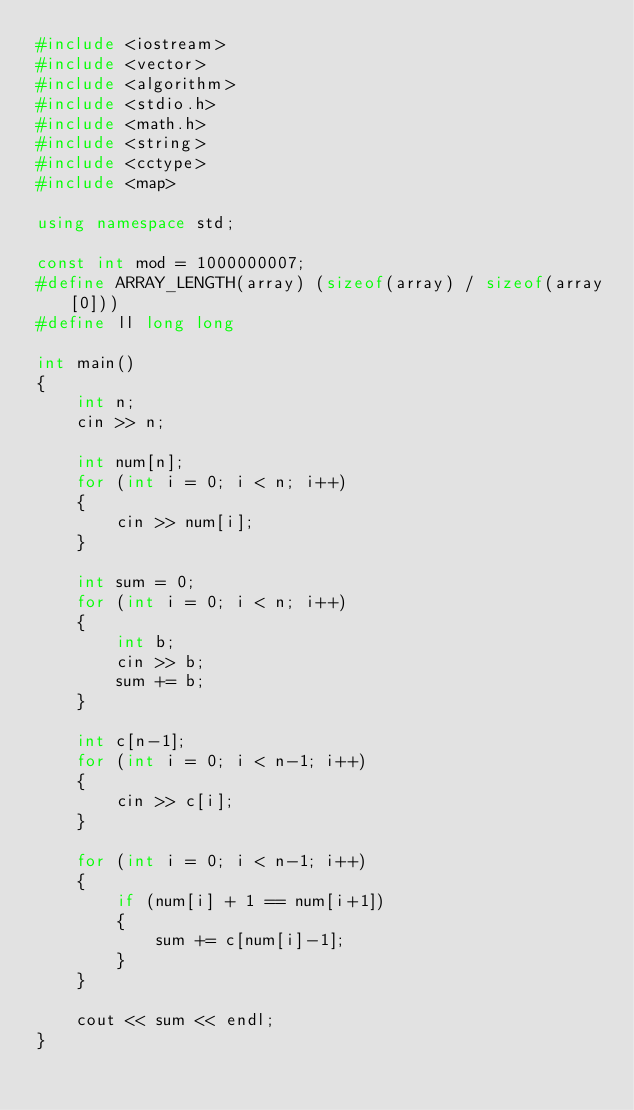<code> <loc_0><loc_0><loc_500><loc_500><_C++_>#include <iostream>
#include <vector>
#include <algorithm>
#include <stdio.h>
#include <math.h>
#include <string>
#include <cctype>
#include <map>

using namespace std;

const int mod = 1000000007;
#define ARRAY_LENGTH(array) (sizeof(array) / sizeof(array[0]))
#define ll long long

int main()
{
    int n;
    cin >> n;

    int num[n];
    for (int i = 0; i < n; i++)
    {
        cin >> num[i];
    }
    
    int sum = 0;
    for (int i = 0; i < n; i++)
    {
        int b;
        cin >> b;
        sum += b;
    }

    int c[n-1];
    for (int i = 0; i < n-1; i++)
    {
        cin >> c[i];
    }

    for (int i = 0; i < n-1; i++)
    {
        if (num[i] + 1 == num[i+1])
        {
            sum += c[num[i]-1];
        }
    }
    
    cout << sum << endl;
}</code> 